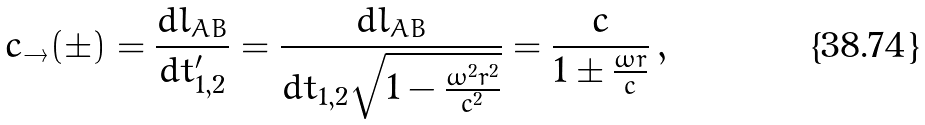<formula> <loc_0><loc_0><loc_500><loc_500>c _ { \rightarrow } ( \pm ) = \frac { d l _ { A B } } { d t ^ { \prime } _ { 1 , 2 } } = \frac { d l _ { A B } } { d t _ { 1 , 2 } \sqrt { 1 - \frac { \omega ^ { 2 } r ^ { 2 } } { c ^ { 2 } } } } = \frac { c } { 1 \pm \frac { \omega r } { c } } \, ,</formula> 